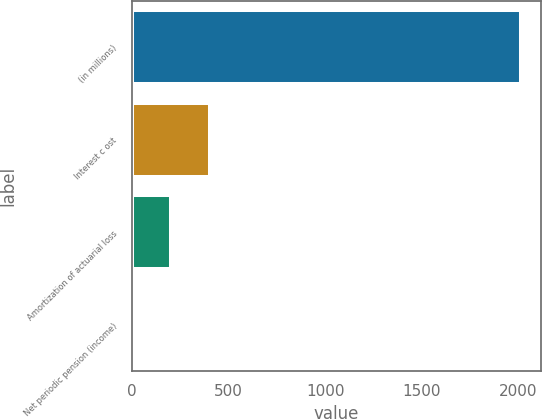Convert chart. <chart><loc_0><loc_0><loc_500><loc_500><bar_chart><fcel>(in millions)<fcel>Interest c ost<fcel>Amortization of actuarial loss<fcel>Net periodic pension (income)<nl><fcel>2016<fcel>404<fcel>202.5<fcel>1<nl></chart> 